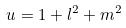Convert formula to latex. <formula><loc_0><loc_0><loc_500><loc_500>u = 1 + l ^ { 2 } + m ^ { 2 }</formula> 